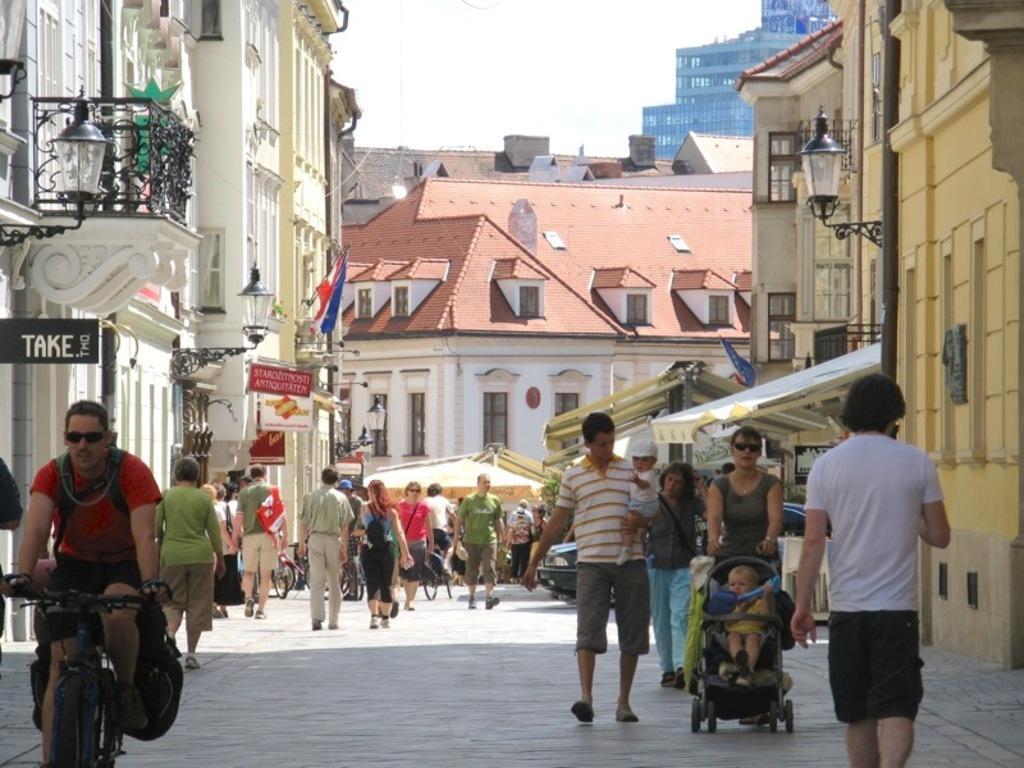How would you summarize this image in a sentence or two? In this image i can see a outside view of an city and there are the two persons walking on the road and left side there is a person riding on big cycle and his wearing a red color t-shirt. And in the left side i can see a white color building and there is a sign board on the left side and there is a light lamp on the left side of the building. And on the in front on image there are the some building on the right side there is another building and there is a pipe line. and right side a man with black color pan this walking on the road and in front him a woman with gray color skirt ,holding a vehicle. on vehicle there is a baby sitting on that. 